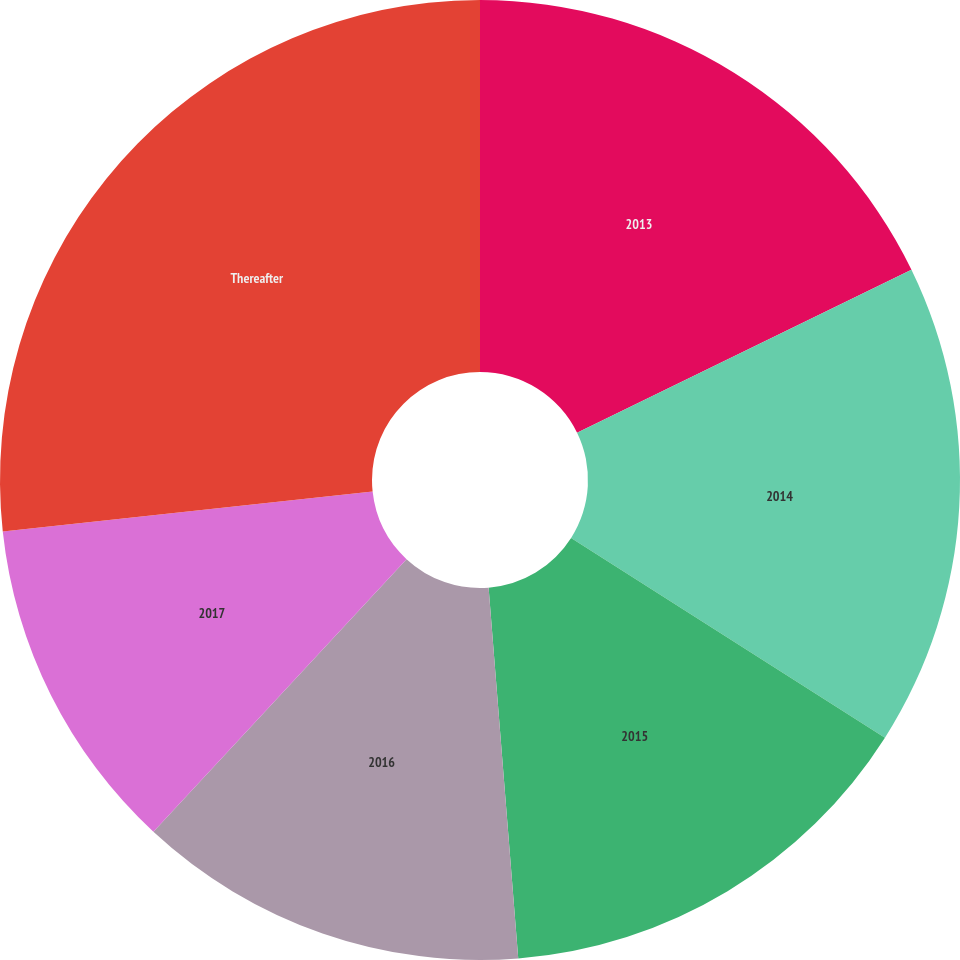Convert chart to OTSL. <chart><loc_0><loc_0><loc_500><loc_500><pie_chart><fcel>2013<fcel>2014<fcel>2015<fcel>2016<fcel>2017<fcel>Thereafter<nl><fcel>17.78%<fcel>16.24%<fcel>14.71%<fcel>13.18%<fcel>11.38%<fcel>26.71%<nl></chart> 